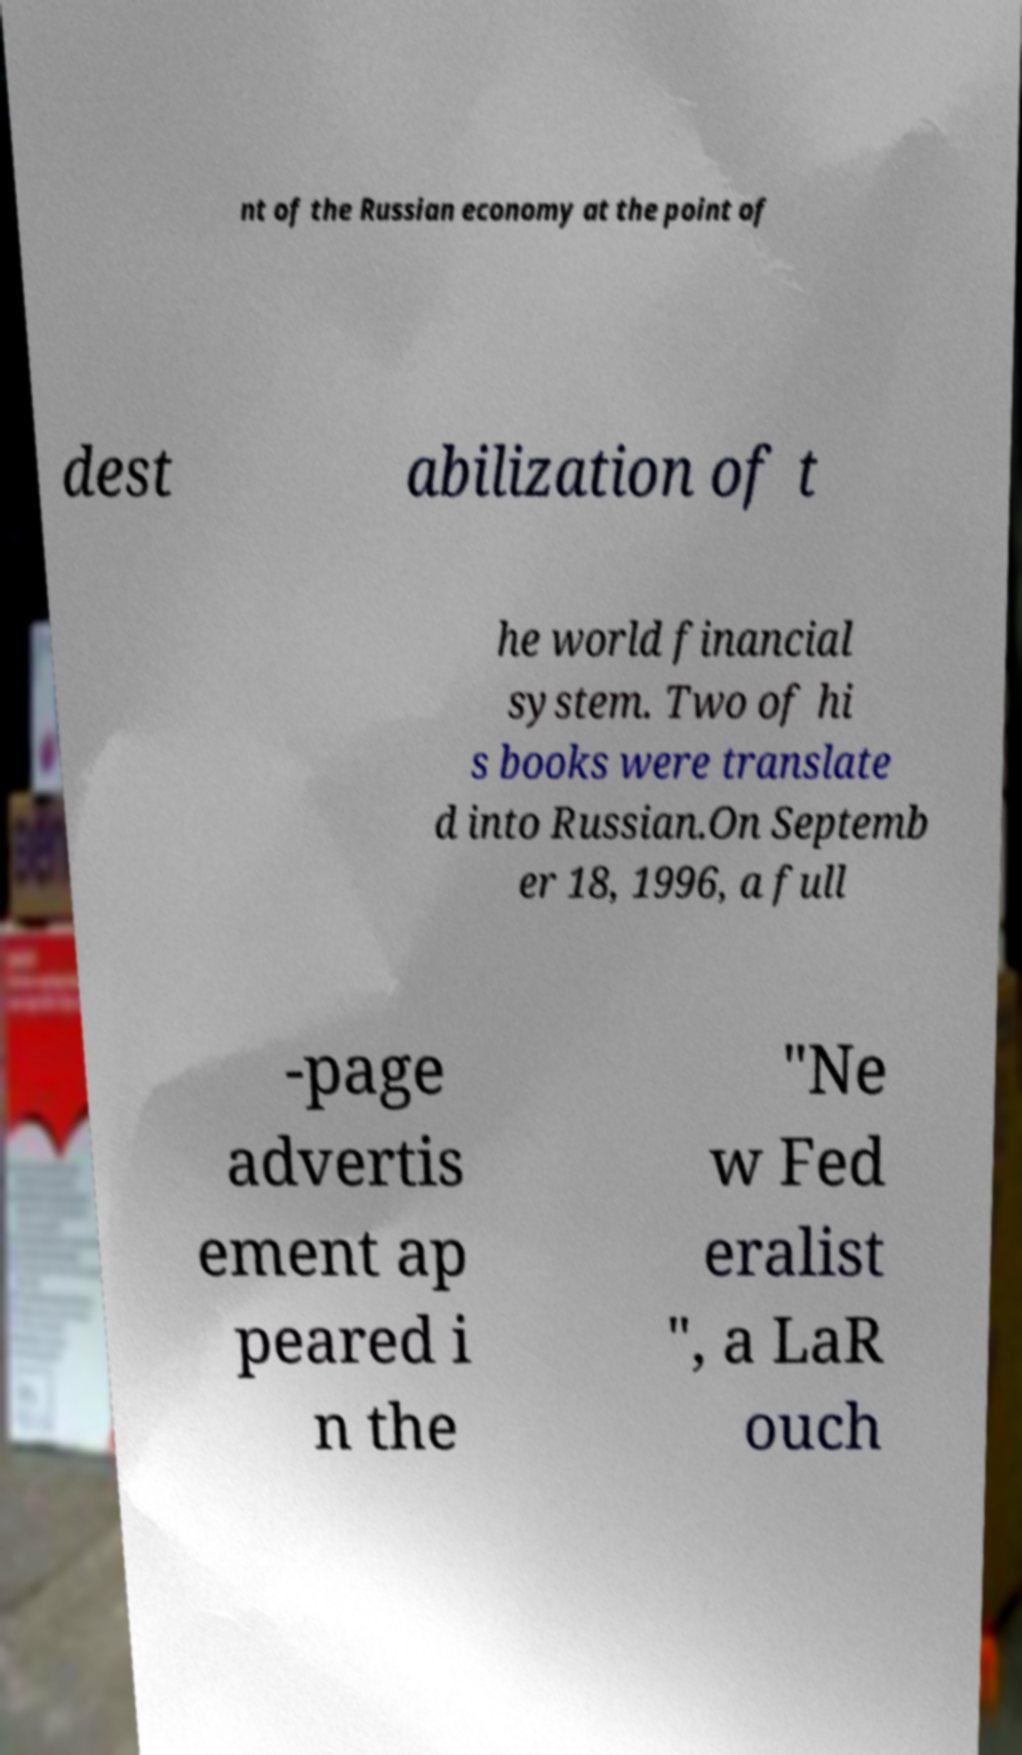Could you assist in decoding the text presented in this image and type it out clearly? nt of the Russian economy at the point of dest abilization of t he world financial system. Two of hi s books were translate d into Russian.On Septemb er 18, 1996, a full -page advertis ement ap peared i n the "Ne w Fed eralist ", a LaR ouch 